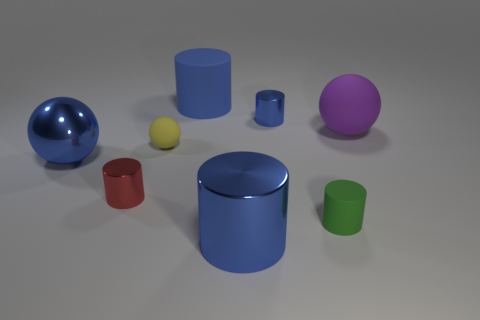Are the yellow object and the big blue sphere made of the same material?
Your response must be concise. No. Are there more tiny green matte cylinders than purple shiny cylinders?
Provide a succinct answer. Yes. Is the number of big objects that are behind the green rubber object greater than the number of small blue metal cylinders behind the small yellow rubber thing?
Your answer should be very brief. Yes. There is a blue object that is both in front of the tiny ball and behind the tiny green rubber cylinder; how big is it?
Give a very brief answer. Large. What number of spheres are the same size as the blue matte object?
Provide a succinct answer. 2. What material is the small thing that is the same color as the large metal ball?
Provide a succinct answer. Metal. Is the shape of the rubber object that is on the right side of the tiny green matte cylinder the same as  the tiny yellow matte thing?
Provide a short and direct response. Yes. Are there fewer cylinders that are on the left side of the yellow rubber thing than big rubber spheres?
Provide a succinct answer. No. Are there any objects that have the same color as the big metal cylinder?
Offer a terse response. Yes. There is a tiny green rubber object; is it the same shape as the large metal thing that is to the right of the tiny red shiny cylinder?
Ensure brevity in your answer.  Yes. 